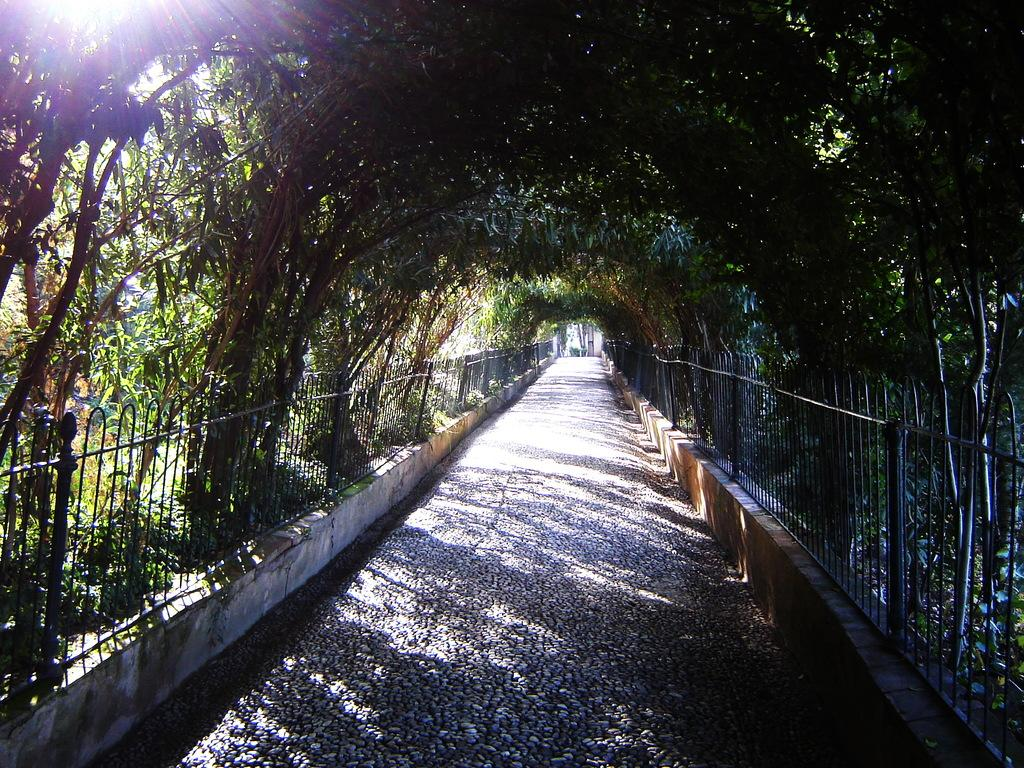What is located in the center of the image? There is a walkway in the center of the image. What can be seen on the left side of the image? There are trees, plants, a railing, and sunshine visible on the left side of the image. What is present on the right side of the image? There are trees and a railing visible on the right side of the image. How many chickens are present in the image? There are no chickens present in the image. What type of vegetable is growing on the right side of the image? There is no vegetable growing in the image; only trees and a railing are visible on the right side. 